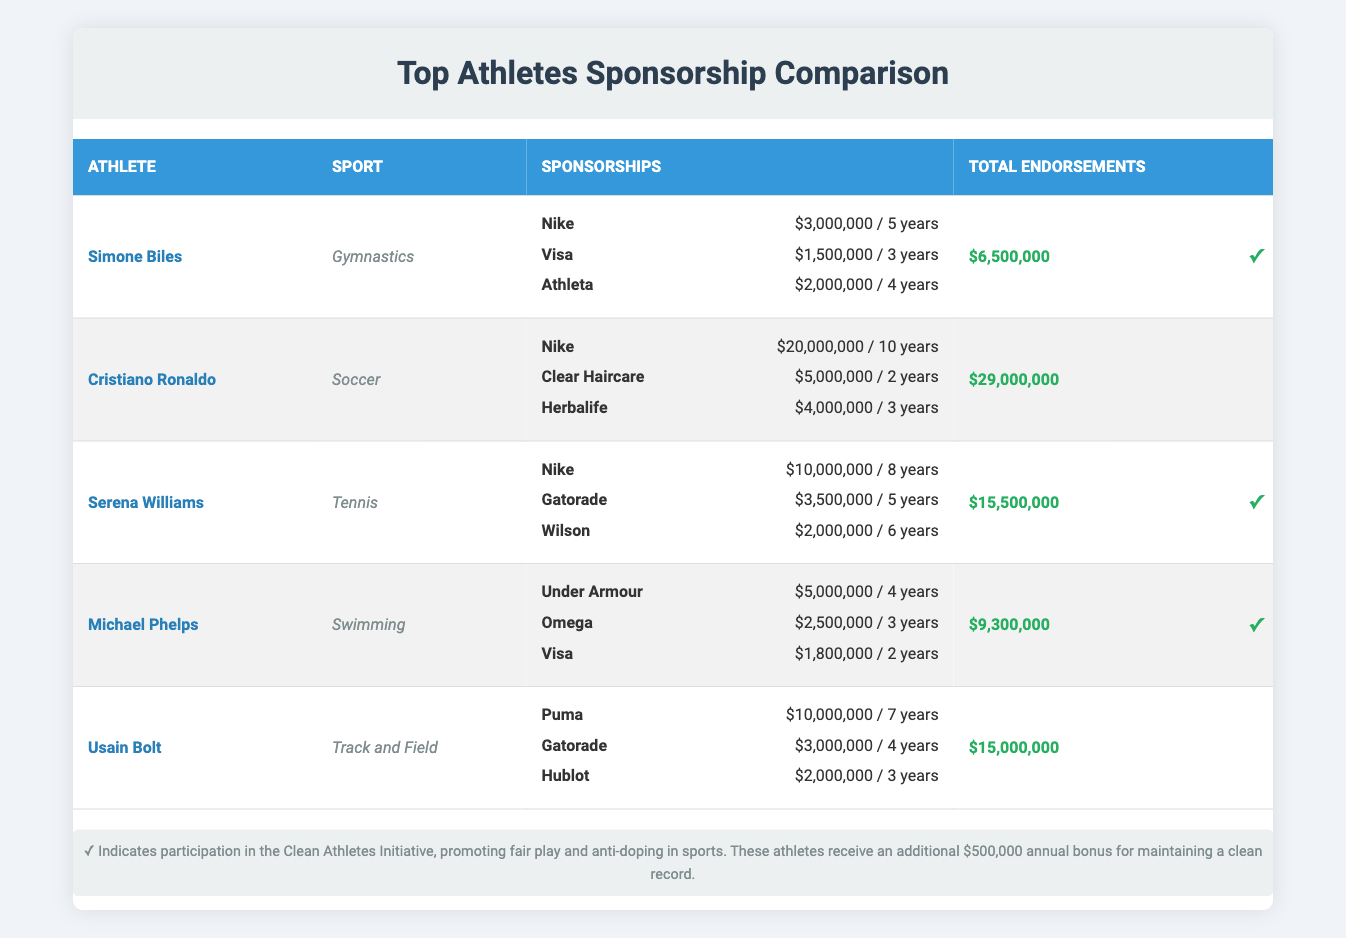What is the total annual value of sponsorship deals for Simone Biles? Simone Biles has three sponsorship deals: Nike worth $3,000,000, Visa worth $1,500,000, and Athleta worth $2,000,000. Adding these values gives: 3,000,000 + 1,500,000 + 2,000,000 = 6,500,000.
Answer: 6,500,000 Who has the highest total endorsements? Looking at the total endorsements column, Cristiano Ronaldo has $29,000,000, which is greater than the totals for the other athletes: Simone Biles ($6,500,000), Serena Williams ($15,500,000), Michael Phelps ($9,300,000), and Usain Bolt ($15,000,000). Therefore, Ronaldo has the highest total endorsements.
Answer: Cristiano Ronaldo Which athlete has the longest contract with a single sponsor? Evaluating the contract lengths for each athlete, Cristiano Ronaldo has the longest contract with Nike for 10 years, compared to other athletes, whose longest contracts are 8 years for Serena Williams (Nike), 7 years for Usain Bolt (Puma), 6 years for Serena Williams (Wilson), 5 years for Simone Biles (Athleta), and Michael Phelps (Gatorade).
Answer: Cristiano Ronaldo Are all athletes participating in the Clean Athletes Initiative? The Clean Athletes Initiative lists three participants: Simone Biles, Serena Williams, and Michael Phelps. Cristiano Ronaldo and Usain Bolt are not mentioned as participants, meaning not all athletes are part of this initiative.
Answer: No What is the average total endorsement amount for clean athletes? The clean athletes are Simone Biles ($6,500,000), Serena Williams ($15,500,000), and Michael Phelps ($9,300,000). Summing these gives 6,500,000 + 15,500,000 + 9,300,000 = 31,300,000. Since there are three athletes, the average is 31,300,000 / 3 = 10,433,333.
Answer: 10,433,333 Which athlete receives an annual bonus for a clean record? According to the information provided, Simone Biles, Serena Williams, and Michael Phelps are participating in the Clean Athletes Initiative, which grants them an annual bonus of $500,000 for maintaining a clean record.
Answer: All of them What is the total value of sponsorships for Usain Bolt? Usain Bolt's sponsorships include Puma ($10,000,000), Gatorade ($3,000,000), and Hublot ($2,000,000). Summing these gives: 10,000,000 + 3,000,000 + 2,000,000 = 15,000,000.
Answer: 15,000,000 